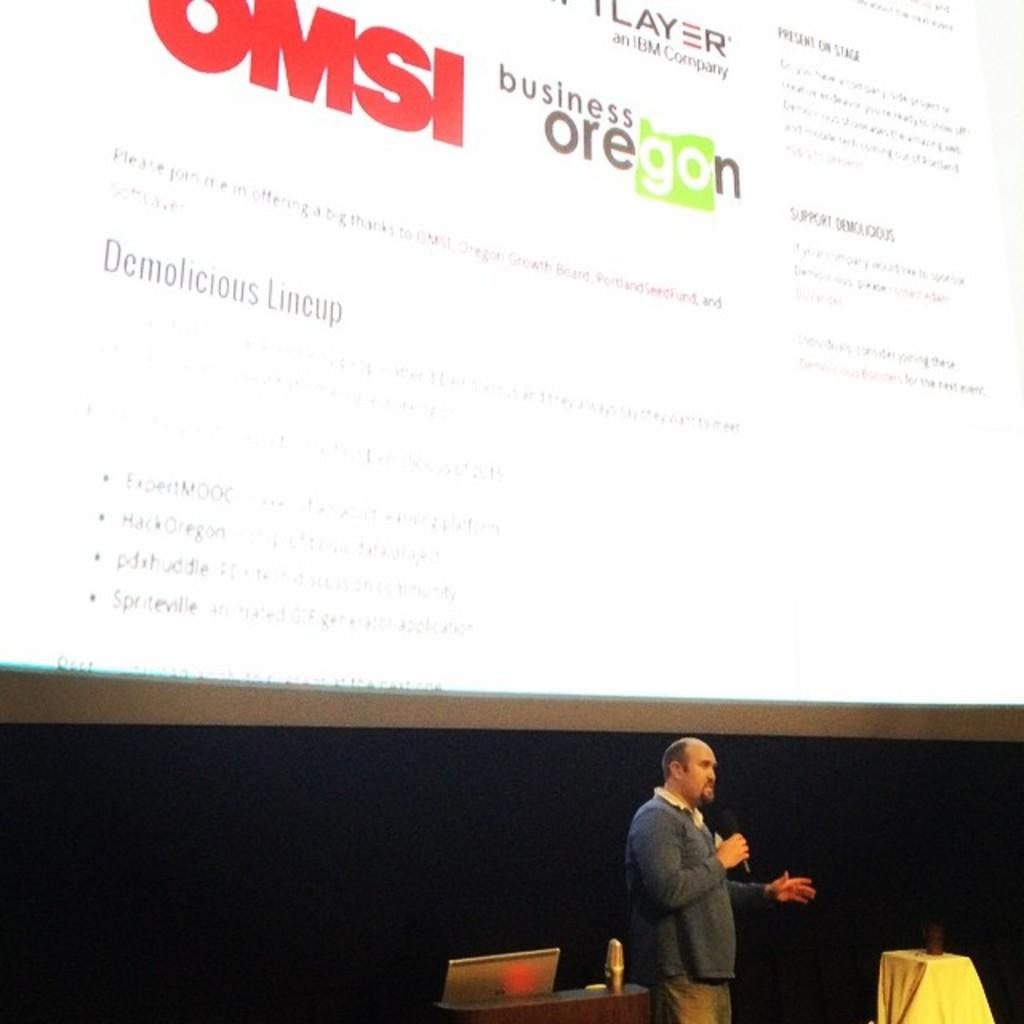What is the man in the image doing? The man is standing at the bottom of the image and speaking into a microphone. What is the man wearing in the image? The man is wearing a coat in the image. What is located at the top of the image? There is a projector screen at the top of the image. Can you see any bees buzzing around the microphone in the image? There are no bees present in the image. What type of thread is being used to sew the curtain in the image? There is no curtain present in the image. 